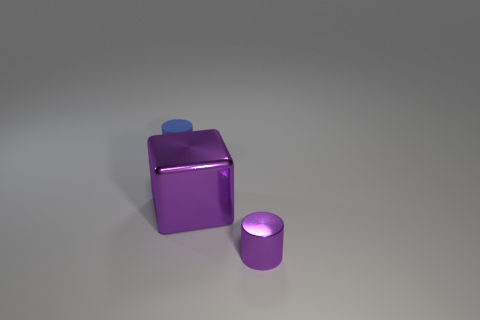Is the color of the tiny metal cylinder the same as the large metallic cube?
Your answer should be very brief. Yes. Are there fewer shiny objects that are behind the tiny blue matte cylinder than blue cylinders that are on the right side of the purple block?
Provide a succinct answer. No. Is there any other thing that has the same shape as the large purple shiny thing?
Your response must be concise. No. There is a thing that is the same color as the large block; what is its material?
Ensure brevity in your answer.  Metal. There is a cylinder that is on the left side of the thing in front of the block; how many small objects are to the right of it?
Your response must be concise. 1. There is a small blue rubber object; how many small metal cylinders are to the right of it?
Offer a very short reply. 1. How many other small cylinders are made of the same material as the tiny purple cylinder?
Your answer should be very brief. 0. There is a tiny thing that is made of the same material as the large purple cube; what color is it?
Offer a terse response. Purple. There is a tiny cylinder that is in front of the shiny thing on the left side of the purple object in front of the large metal cube; what is it made of?
Your answer should be compact. Metal. Does the cylinder in front of the rubber cylinder have the same size as the matte thing?
Give a very brief answer. Yes. 